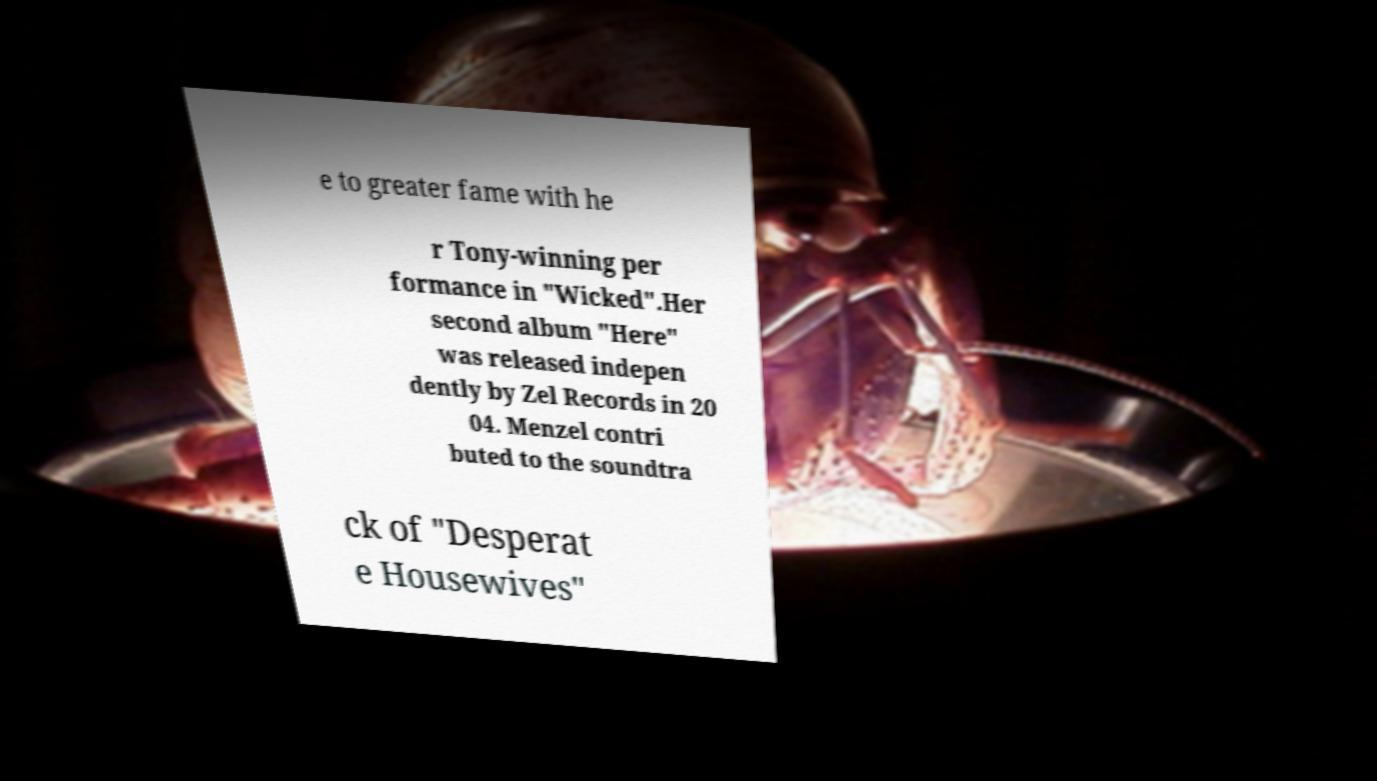Can you read and provide the text displayed in the image?This photo seems to have some interesting text. Can you extract and type it out for me? e to greater fame with he r Tony-winning per formance in "Wicked".Her second album "Here" was released indepen dently by Zel Records in 20 04. Menzel contri buted to the soundtra ck of "Desperat e Housewives" 